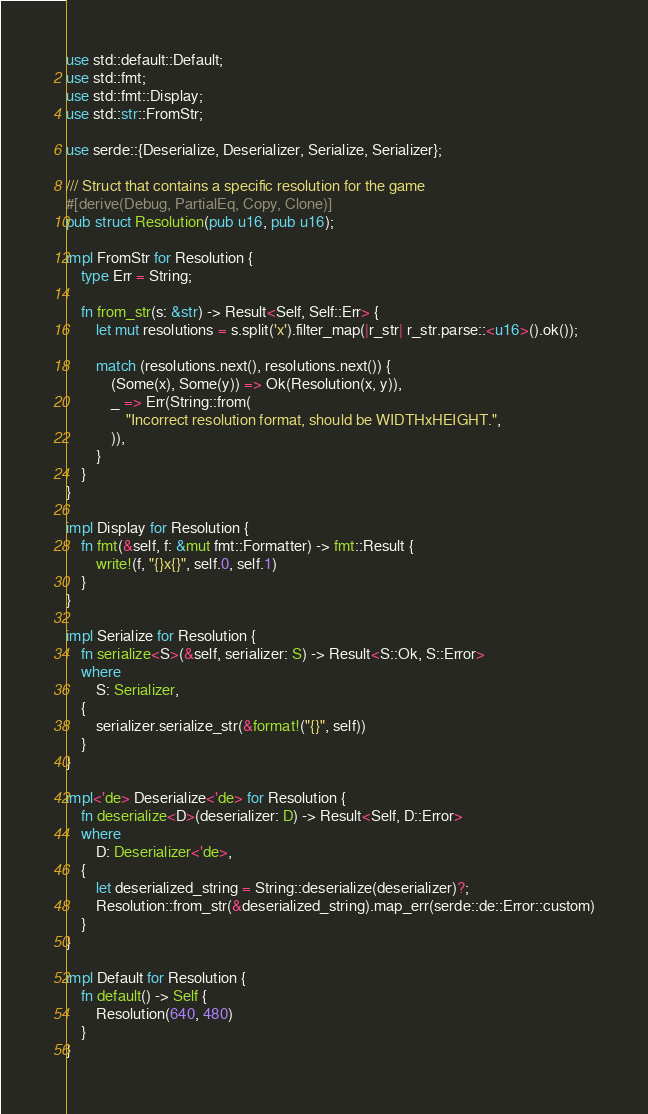Convert code to text. <code><loc_0><loc_0><loc_500><loc_500><_Rust_>use std::default::Default;
use std::fmt;
use std::fmt::Display;
use std::str::FromStr;

use serde::{Deserialize, Deserializer, Serialize, Serializer};

/// Struct that contains a specific resolution for the game
#[derive(Debug, PartialEq, Copy, Clone)]
pub struct Resolution(pub u16, pub u16);

impl FromStr for Resolution {
    type Err = String;

    fn from_str(s: &str) -> Result<Self, Self::Err> {
        let mut resolutions = s.split('x').filter_map(|r_str| r_str.parse::<u16>().ok());

        match (resolutions.next(), resolutions.next()) {
            (Some(x), Some(y)) => Ok(Resolution(x, y)),
            _ => Err(String::from(
                "Incorrect resolution format, should be WIDTHxHEIGHT.",
            )),
        }
    }
}

impl Display for Resolution {
    fn fmt(&self, f: &mut fmt::Formatter) -> fmt::Result {
        write!(f, "{}x{}", self.0, self.1)
    }
}

impl Serialize for Resolution {
    fn serialize<S>(&self, serializer: S) -> Result<S::Ok, S::Error>
    where
        S: Serializer,
    {
        serializer.serialize_str(&format!("{}", self))
    }
}

impl<'de> Deserialize<'de> for Resolution {
    fn deserialize<D>(deserializer: D) -> Result<Self, D::Error>
    where
        D: Deserializer<'de>,
    {
        let deserialized_string = String::deserialize(deserializer)?;
        Resolution::from_str(&deserialized_string).map_err(serde::de::Error::custom)
    }
}

impl Default for Resolution {
    fn default() -> Self {
        Resolution(640, 480)
    }
}
</code> 